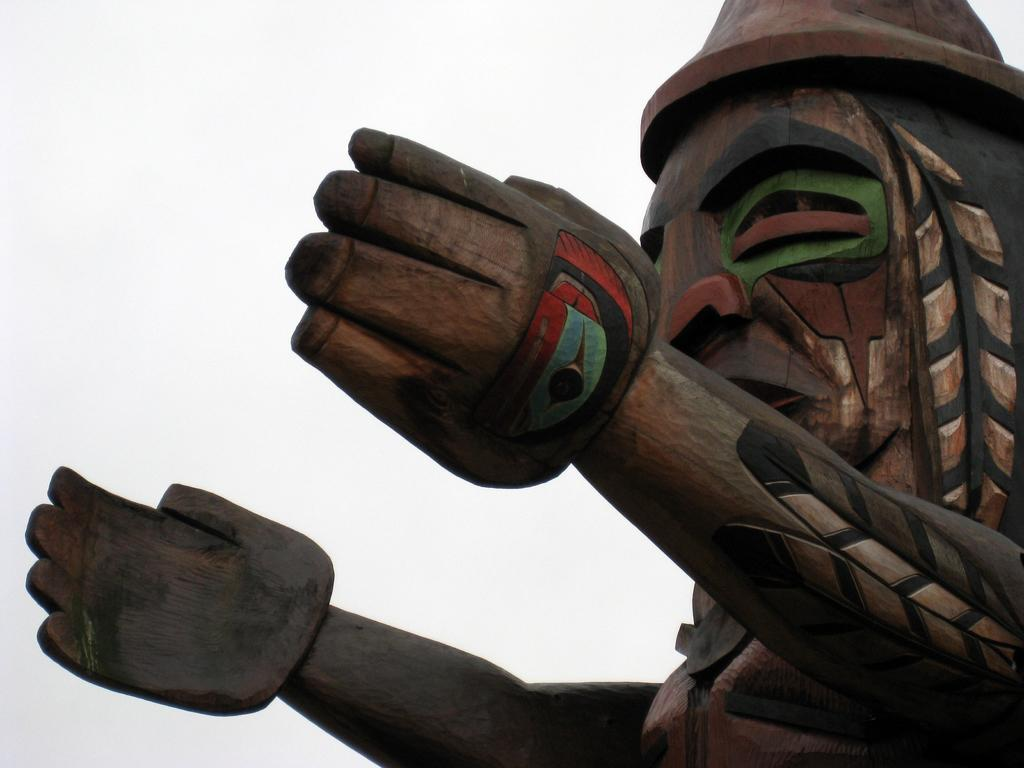What type of sculpture is in the image? There is a wooden sculpture in the image. What is the subject of the wooden sculpture? The sculpture is of a tribal man. Are there any colors on the wooden sculpture? Yes, the sculpture has some colors on it. What can be seen in the background of the image? There is a sky visible in the background of the image. What type of support does the zebra use to stand in the image? There is no zebra present in the image, so there is no support for a zebra to stand on. 